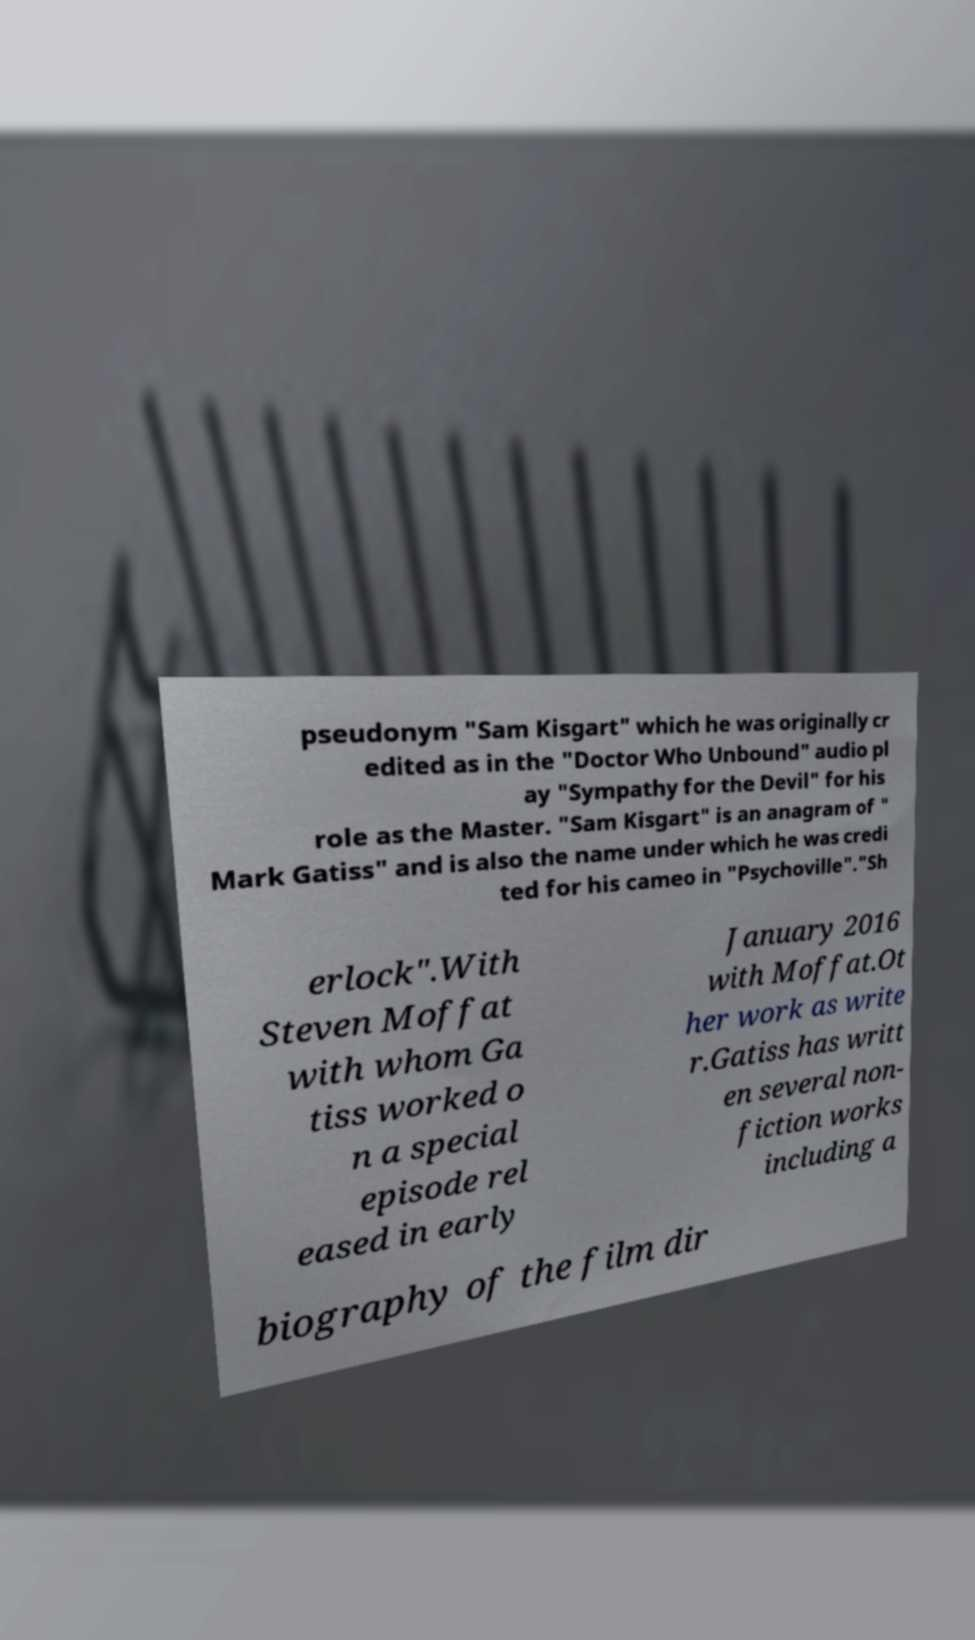Please identify and transcribe the text found in this image. pseudonym "Sam Kisgart" which he was originally cr edited as in the "Doctor Who Unbound" audio pl ay "Sympathy for the Devil" for his role as the Master. "Sam Kisgart" is an anagram of " Mark Gatiss" and is also the name under which he was credi ted for his cameo in "Psychoville"."Sh erlock".With Steven Moffat with whom Ga tiss worked o n a special episode rel eased in early January 2016 with Moffat.Ot her work as write r.Gatiss has writt en several non- fiction works including a biography of the film dir 